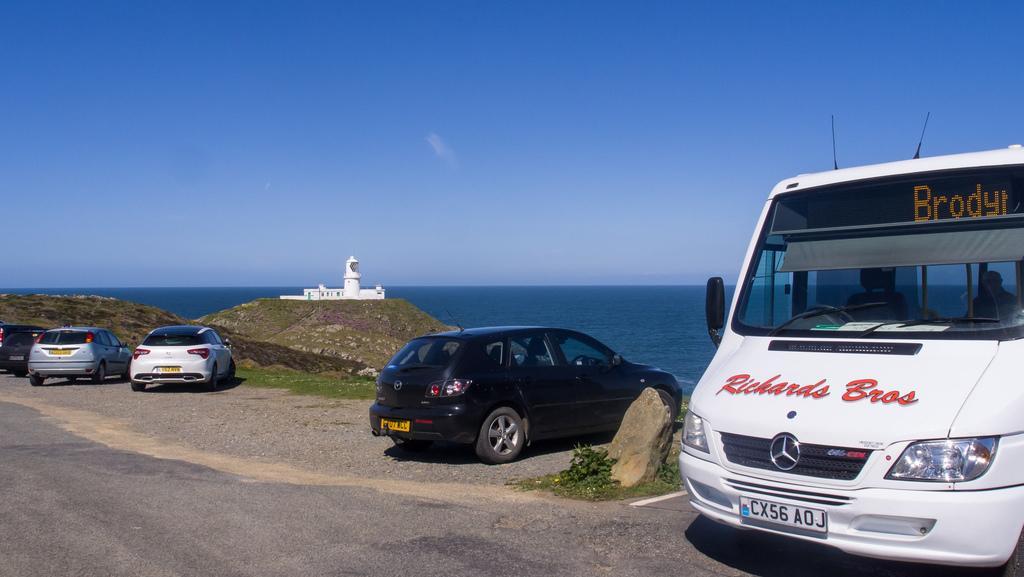Can you describe this image briefly? In this image I can see few vehicles. In the background I can see the building in white color and I can also see the water and the sky is in blue color. 